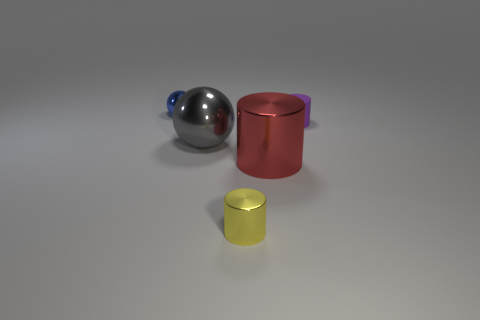Can you tell me which objects might be heavier and why? The objects' weight cannot be determined with certainty from the image alone, but assuming they are made from the same material, we can infer that the larger red cylinder would be the heaviest due to its size and volume. The sphere would likely be the next heaviest, and the tiny yellow cylinder the lightest. Based on their appearances, what materials could these objects be made of? Judging by their appearances, the large red cylinder and the reflective sphere might be made of a type of metal, given their lustrous surfaces. The tiny yellow cylinder could be made of a matte plastic or a similar non-metallic material, as it doesn't reflect light as the other two objects do. 